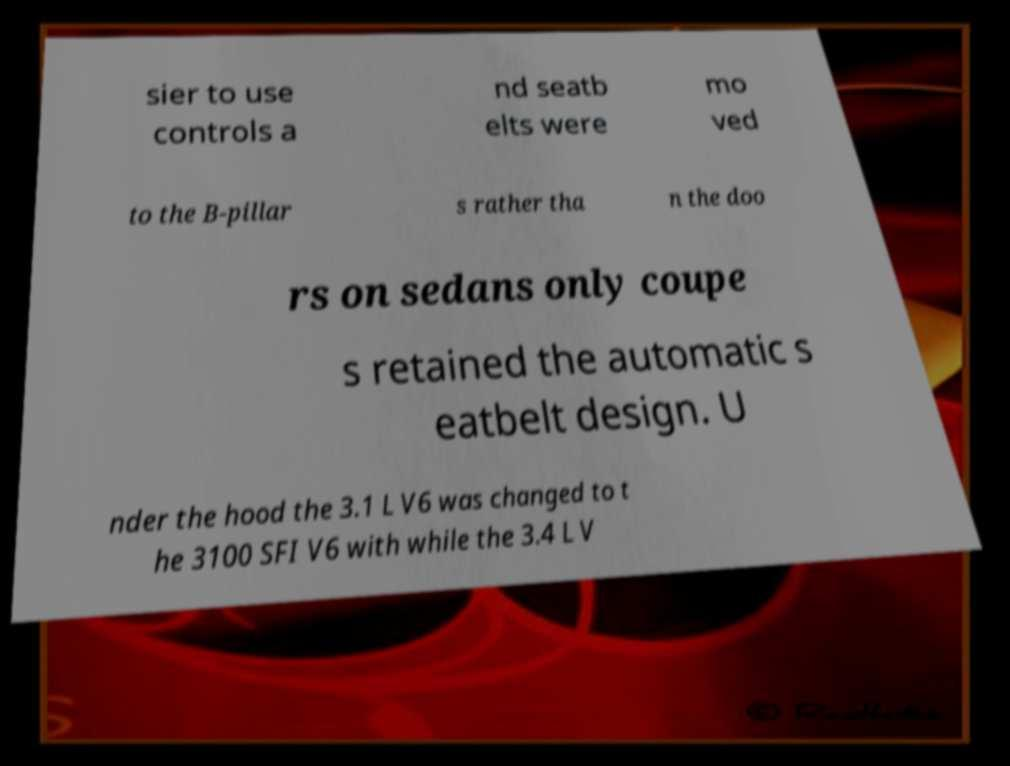There's text embedded in this image that I need extracted. Can you transcribe it verbatim? sier to use controls a nd seatb elts were mo ved to the B-pillar s rather tha n the doo rs on sedans only coupe s retained the automatic s eatbelt design. U nder the hood the 3.1 L V6 was changed to t he 3100 SFI V6 with while the 3.4 L V 